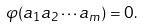Convert formula to latex. <formula><loc_0><loc_0><loc_500><loc_500>\varphi ( a _ { 1 } a _ { 2 } \cdots a _ { m } ) = 0 .</formula> 